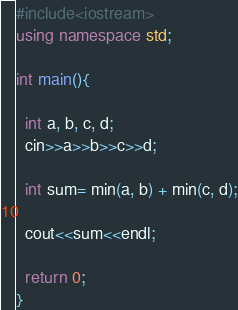<code> <loc_0><loc_0><loc_500><loc_500><_C++_>#include<iostream>
using namespace std;

int main(){
  
  int a, b, c, d;
  cin>>a>>b>>c>>d;
  
  int sum= min(a, b) + min(c, d);
  
  cout<<sum<<endl;
  
  return 0;
}</code> 